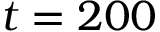<formula> <loc_0><loc_0><loc_500><loc_500>t = 2 0 0</formula> 